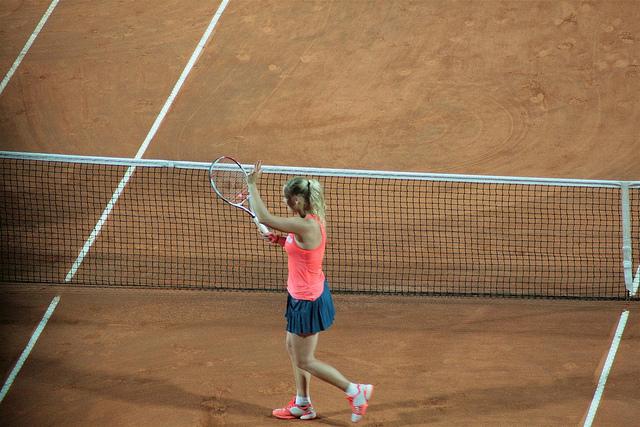What game is she playing?
Keep it brief. Tennis. Is the woman dancing?
Give a very brief answer. No. How many people in this photo?
Give a very brief answer. 1. 